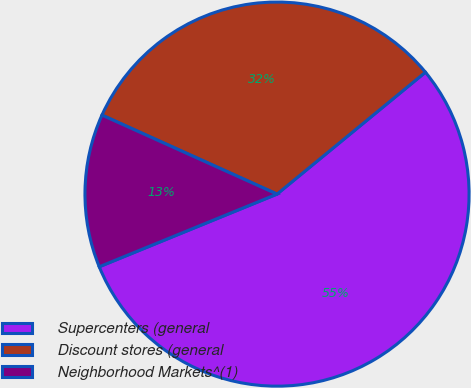<chart> <loc_0><loc_0><loc_500><loc_500><pie_chart><fcel>Supercenters (general<fcel>Discount stores (general<fcel>Neighborhood Markets^(1)<nl><fcel>54.77%<fcel>32.31%<fcel>12.92%<nl></chart> 